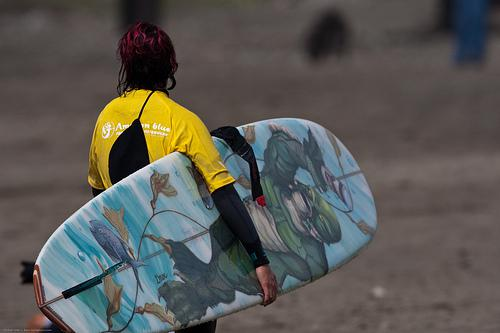Question: where was the photo taken?
Choices:
A. Ocean.
B. Lake.
C. Beach.
D. Park.
Answer with the letter. Answer: C Question: what is the person holding?
Choices:
A. Wakeboard.
B. Umbrella.
C. Cooler.
D. Surfboard.
Answer with the letter. Answer: D 